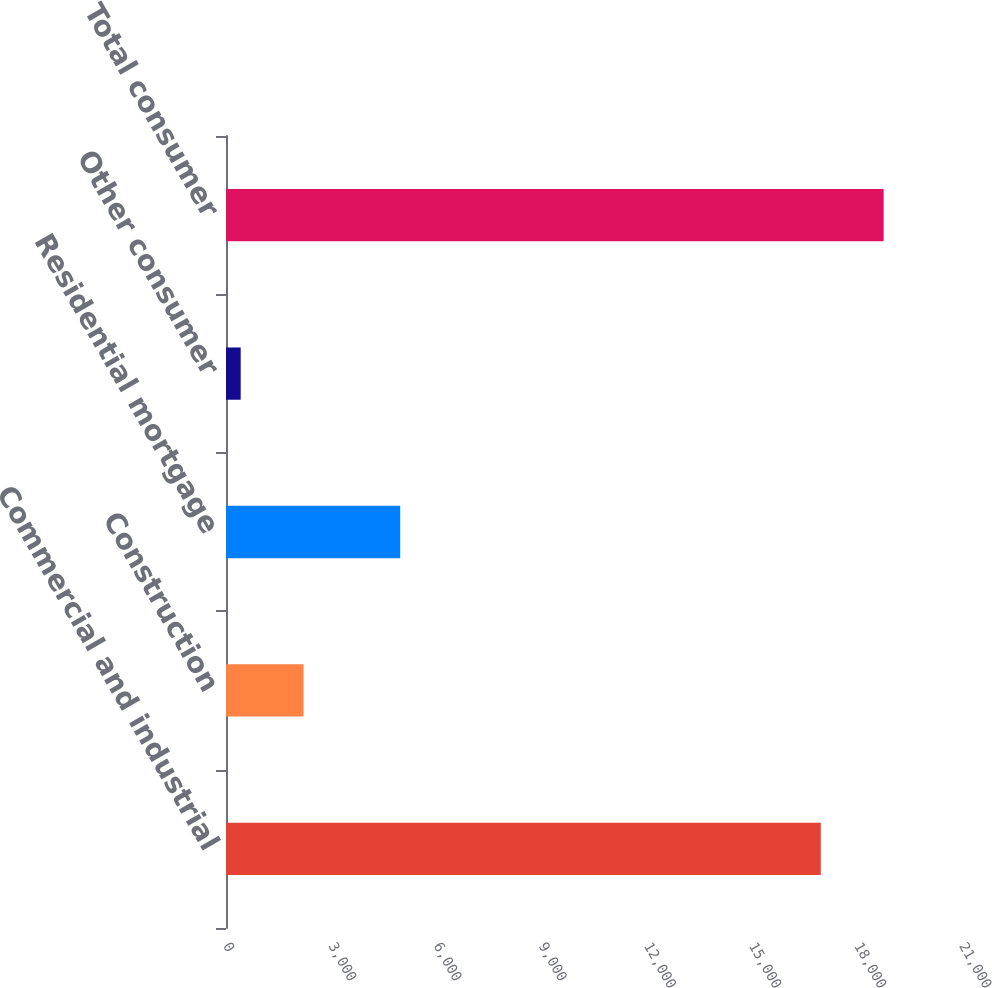Convert chart. <chart><loc_0><loc_0><loc_500><loc_500><bar_chart><fcel>Commercial and industrial<fcel>Construction<fcel>Residential mortgage<fcel>Other consumer<fcel>Total consumer<nl><fcel>16971<fcel>2212.9<fcel>4970<fcel>419<fcel>18764.9<nl></chart> 